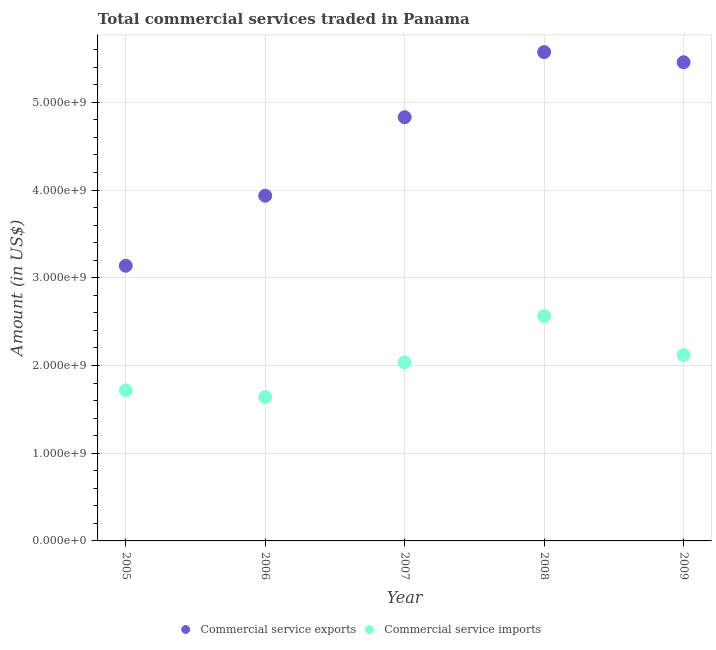How many different coloured dotlines are there?
Offer a terse response. 2. Is the number of dotlines equal to the number of legend labels?
Give a very brief answer. Yes. What is the amount of commercial service exports in 2007?
Offer a very short reply. 4.83e+09. Across all years, what is the maximum amount of commercial service exports?
Ensure brevity in your answer.  5.57e+09. Across all years, what is the minimum amount of commercial service exports?
Offer a very short reply. 3.14e+09. In which year was the amount of commercial service imports maximum?
Offer a terse response. 2008. In which year was the amount of commercial service imports minimum?
Give a very brief answer. 2006. What is the total amount of commercial service imports in the graph?
Keep it short and to the point. 1.01e+1. What is the difference between the amount of commercial service exports in 2007 and that in 2008?
Your answer should be compact. -7.42e+08. What is the difference between the amount of commercial service imports in 2007 and the amount of commercial service exports in 2005?
Offer a terse response. -1.10e+09. What is the average amount of commercial service imports per year?
Make the answer very short. 2.02e+09. In the year 2008, what is the difference between the amount of commercial service imports and amount of commercial service exports?
Offer a very short reply. -3.01e+09. What is the ratio of the amount of commercial service exports in 2006 to that in 2009?
Your answer should be very brief. 0.72. Is the amount of commercial service exports in 2005 less than that in 2008?
Provide a succinct answer. Yes. Is the difference between the amount of commercial service exports in 2005 and 2009 greater than the difference between the amount of commercial service imports in 2005 and 2009?
Offer a terse response. No. What is the difference between the highest and the second highest amount of commercial service exports?
Your answer should be compact. 1.16e+08. What is the difference between the highest and the lowest amount of commercial service imports?
Offer a very short reply. 9.22e+08. In how many years, is the amount of commercial service exports greater than the average amount of commercial service exports taken over all years?
Your answer should be very brief. 3. Does the amount of commercial service imports monotonically increase over the years?
Your answer should be compact. No. How many dotlines are there?
Your answer should be compact. 2. How many years are there in the graph?
Your response must be concise. 5. What is the difference between two consecutive major ticks on the Y-axis?
Provide a succinct answer. 1.00e+09. Are the values on the major ticks of Y-axis written in scientific E-notation?
Make the answer very short. Yes. Does the graph contain any zero values?
Your answer should be compact. No. Does the graph contain grids?
Offer a terse response. Yes. How many legend labels are there?
Ensure brevity in your answer.  2. How are the legend labels stacked?
Make the answer very short. Horizontal. What is the title of the graph?
Your response must be concise. Total commercial services traded in Panama. Does "International Tourists" appear as one of the legend labels in the graph?
Give a very brief answer. No. What is the label or title of the X-axis?
Give a very brief answer. Year. What is the Amount (in US$) of Commercial service exports in 2005?
Make the answer very short. 3.14e+09. What is the Amount (in US$) of Commercial service imports in 2005?
Your response must be concise. 1.72e+09. What is the Amount (in US$) in Commercial service exports in 2006?
Your answer should be very brief. 3.94e+09. What is the Amount (in US$) in Commercial service imports in 2006?
Your response must be concise. 1.64e+09. What is the Amount (in US$) of Commercial service exports in 2007?
Make the answer very short. 4.83e+09. What is the Amount (in US$) in Commercial service imports in 2007?
Give a very brief answer. 2.04e+09. What is the Amount (in US$) of Commercial service exports in 2008?
Your answer should be very brief. 5.57e+09. What is the Amount (in US$) in Commercial service imports in 2008?
Make the answer very short. 2.56e+09. What is the Amount (in US$) in Commercial service exports in 2009?
Keep it short and to the point. 5.46e+09. What is the Amount (in US$) in Commercial service imports in 2009?
Ensure brevity in your answer.  2.12e+09. Across all years, what is the maximum Amount (in US$) in Commercial service exports?
Ensure brevity in your answer.  5.57e+09. Across all years, what is the maximum Amount (in US$) of Commercial service imports?
Your answer should be compact. 2.56e+09. Across all years, what is the minimum Amount (in US$) in Commercial service exports?
Offer a terse response. 3.14e+09. Across all years, what is the minimum Amount (in US$) of Commercial service imports?
Make the answer very short. 1.64e+09. What is the total Amount (in US$) of Commercial service exports in the graph?
Your answer should be very brief. 2.29e+1. What is the total Amount (in US$) of Commercial service imports in the graph?
Offer a very short reply. 1.01e+1. What is the difference between the Amount (in US$) in Commercial service exports in 2005 and that in 2006?
Your answer should be compact. -7.99e+08. What is the difference between the Amount (in US$) of Commercial service imports in 2005 and that in 2006?
Your response must be concise. 7.55e+07. What is the difference between the Amount (in US$) of Commercial service exports in 2005 and that in 2007?
Keep it short and to the point. -1.69e+09. What is the difference between the Amount (in US$) in Commercial service imports in 2005 and that in 2007?
Provide a succinct answer. -3.20e+08. What is the difference between the Amount (in US$) of Commercial service exports in 2005 and that in 2008?
Offer a very short reply. -2.44e+09. What is the difference between the Amount (in US$) of Commercial service imports in 2005 and that in 2008?
Ensure brevity in your answer.  -8.46e+08. What is the difference between the Amount (in US$) in Commercial service exports in 2005 and that in 2009?
Make the answer very short. -2.32e+09. What is the difference between the Amount (in US$) in Commercial service imports in 2005 and that in 2009?
Offer a terse response. -4.02e+08. What is the difference between the Amount (in US$) in Commercial service exports in 2006 and that in 2007?
Keep it short and to the point. -8.95e+08. What is the difference between the Amount (in US$) of Commercial service imports in 2006 and that in 2007?
Your answer should be compact. -3.96e+08. What is the difference between the Amount (in US$) of Commercial service exports in 2006 and that in 2008?
Provide a short and direct response. -1.64e+09. What is the difference between the Amount (in US$) of Commercial service imports in 2006 and that in 2008?
Offer a very short reply. -9.22e+08. What is the difference between the Amount (in US$) in Commercial service exports in 2006 and that in 2009?
Your response must be concise. -1.52e+09. What is the difference between the Amount (in US$) in Commercial service imports in 2006 and that in 2009?
Your answer should be very brief. -4.77e+08. What is the difference between the Amount (in US$) of Commercial service exports in 2007 and that in 2008?
Provide a short and direct response. -7.42e+08. What is the difference between the Amount (in US$) in Commercial service imports in 2007 and that in 2008?
Offer a terse response. -5.26e+08. What is the difference between the Amount (in US$) in Commercial service exports in 2007 and that in 2009?
Offer a very short reply. -6.27e+08. What is the difference between the Amount (in US$) in Commercial service imports in 2007 and that in 2009?
Provide a succinct answer. -8.15e+07. What is the difference between the Amount (in US$) of Commercial service exports in 2008 and that in 2009?
Give a very brief answer. 1.16e+08. What is the difference between the Amount (in US$) of Commercial service imports in 2008 and that in 2009?
Keep it short and to the point. 4.45e+08. What is the difference between the Amount (in US$) of Commercial service exports in 2005 and the Amount (in US$) of Commercial service imports in 2006?
Give a very brief answer. 1.50e+09. What is the difference between the Amount (in US$) in Commercial service exports in 2005 and the Amount (in US$) in Commercial service imports in 2007?
Provide a succinct answer. 1.10e+09. What is the difference between the Amount (in US$) of Commercial service exports in 2005 and the Amount (in US$) of Commercial service imports in 2008?
Make the answer very short. 5.74e+08. What is the difference between the Amount (in US$) of Commercial service exports in 2005 and the Amount (in US$) of Commercial service imports in 2009?
Your response must be concise. 1.02e+09. What is the difference between the Amount (in US$) in Commercial service exports in 2006 and the Amount (in US$) in Commercial service imports in 2007?
Ensure brevity in your answer.  1.90e+09. What is the difference between the Amount (in US$) in Commercial service exports in 2006 and the Amount (in US$) in Commercial service imports in 2008?
Offer a terse response. 1.37e+09. What is the difference between the Amount (in US$) in Commercial service exports in 2006 and the Amount (in US$) in Commercial service imports in 2009?
Provide a short and direct response. 1.82e+09. What is the difference between the Amount (in US$) of Commercial service exports in 2007 and the Amount (in US$) of Commercial service imports in 2008?
Offer a terse response. 2.27e+09. What is the difference between the Amount (in US$) in Commercial service exports in 2007 and the Amount (in US$) in Commercial service imports in 2009?
Offer a terse response. 2.71e+09. What is the difference between the Amount (in US$) of Commercial service exports in 2008 and the Amount (in US$) of Commercial service imports in 2009?
Your answer should be compact. 3.45e+09. What is the average Amount (in US$) of Commercial service exports per year?
Provide a succinct answer. 4.59e+09. What is the average Amount (in US$) in Commercial service imports per year?
Give a very brief answer. 2.02e+09. In the year 2005, what is the difference between the Amount (in US$) of Commercial service exports and Amount (in US$) of Commercial service imports?
Make the answer very short. 1.42e+09. In the year 2006, what is the difference between the Amount (in US$) in Commercial service exports and Amount (in US$) in Commercial service imports?
Give a very brief answer. 2.29e+09. In the year 2007, what is the difference between the Amount (in US$) in Commercial service exports and Amount (in US$) in Commercial service imports?
Your answer should be compact. 2.79e+09. In the year 2008, what is the difference between the Amount (in US$) in Commercial service exports and Amount (in US$) in Commercial service imports?
Keep it short and to the point. 3.01e+09. In the year 2009, what is the difference between the Amount (in US$) of Commercial service exports and Amount (in US$) of Commercial service imports?
Offer a terse response. 3.34e+09. What is the ratio of the Amount (in US$) of Commercial service exports in 2005 to that in 2006?
Keep it short and to the point. 0.8. What is the ratio of the Amount (in US$) in Commercial service imports in 2005 to that in 2006?
Your answer should be compact. 1.05. What is the ratio of the Amount (in US$) of Commercial service exports in 2005 to that in 2007?
Offer a very short reply. 0.65. What is the ratio of the Amount (in US$) of Commercial service imports in 2005 to that in 2007?
Give a very brief answer. 0.84. What is the ratio of the Amount (in US$) of Commercial service exports in 2005 to that in 2008?
Keep it short and to the point. 0.56. What is the ratio of the Amount (in US$) of Commercial service imports in 2005 to that in 2008?
Keep it short and to the point. 0.67. What is the ratio of the Amount (in US$) in Commercial service exports in 2005 to that in 2009?
Your answer should be compact. 0.57. What is the ratio of the Amount (in US$) of Commercial service imports in 2005 to that in 2009?
Give a very brief answer. 0.81. What is the ratio of the Amount (in US$) of Commercial service exports in 2006 to that in 2007?
Your answer should be very brief. 0.81. What is the ratio of the Amount (in US$) in Commercial service imports in 2006 to that in 2007?
Offer a terse response. 0.81. What is the ratio of the Amount (in US$) of Commercial service exports in 2006 to that in 2008?
Offer a very short reply. 0.71. What is the ratio of the Amount (in US$) in Commercial service imports in 2006 to that in 2008?
Your response must be concise. 0.64. What is the ratio of the Amount (in US$) of Commercial service exports in 2006 to that in 2009?
Ensure brevity in your answer.  0.72. What is the ratio of the Amount (in US$) of Commercial service imports in 2006 to that in 2009?
Your response must be concise. 0.77. What is the ratio of the Amount (in US$) in Commercial service exports in 2007 to that in 2008?
Ensure brevity in your answer.  0.87. What is the ratio of the Amount (in US$) in Commercial service imports in 2007 to that in 2008?
Your answer should be compact. 0.79. What is the ratio of the Amount (in US$) of Commercial service exports in 2007 to that in 2009?
Give a very brief answer. 0.89. What is the ratio of the Amount (in US$) in Commercial service imports in 2007 to that in 2009?
Provide a succinct answer. 0.96. What is the ratio of the Amount (in US$) in Commercial service exports in 2008 to that in 2009?
Offer a very short reply. 1.02. What is the ratio of the Amount (in US$) of Commercial service imports in 2008 to that in 2009?
Offer a terse response. 1.21. What is the difference between the highest and the second highest Amount (in US$) of Commercial service exports?
Your answer should be very brief. 1.16e+08. What is the difference between the highest and the second highest Amount (in US$) in Commercial service imports?
Keep it short and to the point. 4.45e+08. What is the difference between the highest and the lowest Amount (in US$) in Commercial service exports?
Provide a succinct answer. 2.44e+09. What is the difference between the highest and the lowest Amount (in US$) of Commercial service imports?
Keep it short and to the point. 9.22e+08. 